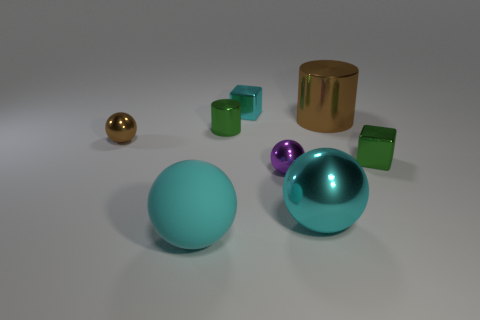What number of cyan balls are the same material as the cyan cube?
Offer a very short reply. 1. There is a green object that is the same shape as the large brown metallic thing; what size is it?
Provide a short and direct response. Small. What is the material of the big brown cylinder?
Give a very brief answer. Metal. What material is the cyan ball that is left of the metallic cube to the left of the green thing right of the big metallic cylinder?
Offer a very short reply. Rubber. Is there any other thing that is the same shape as the small purple thing?
Your response must be concise. Yes. There is a matte thing that is the same shape as the purple metal thing; what color is it?
Your response must be concise. Cyan. Is the color of the block that is on the right side of the big brown thing the same as the metallic cylinder to the left of the large cyan shiny ball?
Provide a short and direct response. Yes. Is the number of small green metal objects that are behind the large cyan metal ball greater than the number of big gray rubber cylinders?
Provide a short and direct response. Yes. What number of other objects are the same size as the purple sphere?
Provide a short and direct response. 4. How many objects are both in front of the tiny green shiny cylinder and on the right side of the small brown object?
Ensure brevity in your answer.  4. 